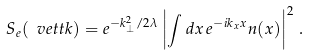<formula> <loc_0><loc_0><loc_500><loc_500>S _ { e } ( \ v e t t k ) = e ^ { - k _ { \perp } ^ { 2 } / 2 \lambda } \left | \int d x \, e ^ { - i k _ { x } x } n ( x ) \right | ^ { 2 } \, .</formula> 